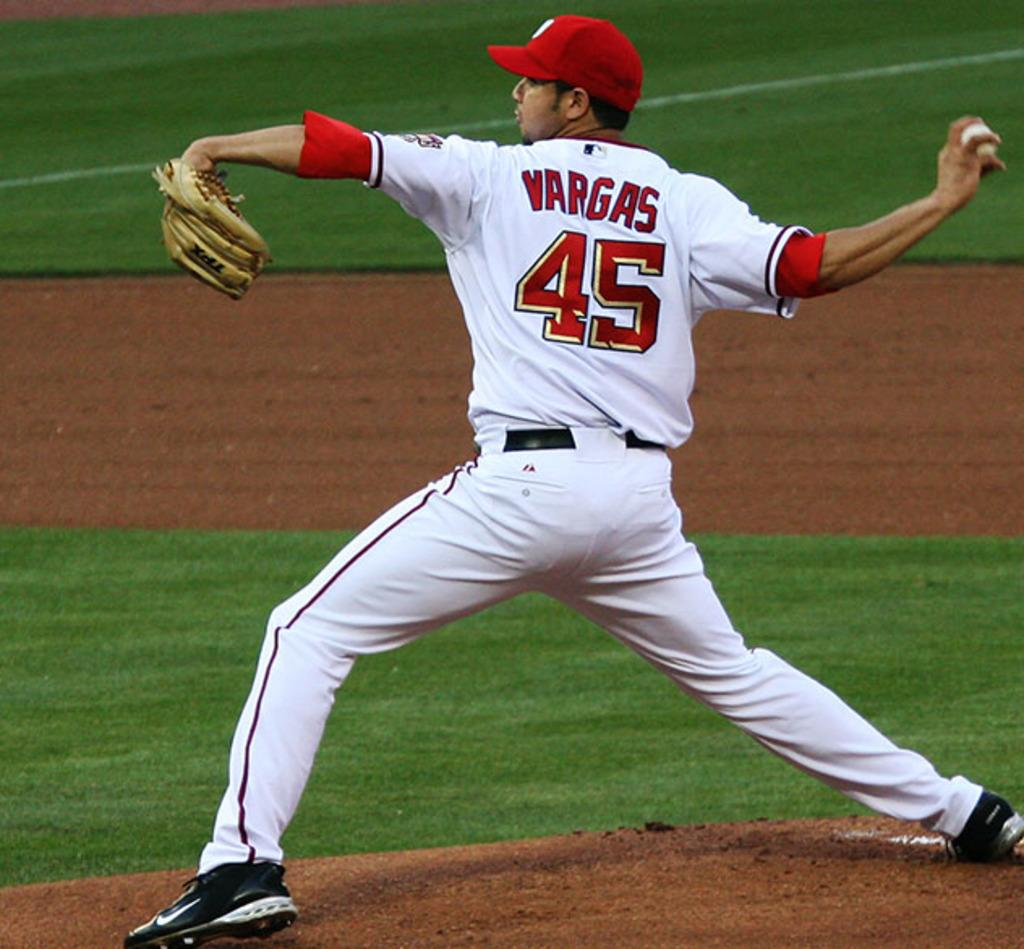Provide a one-sentence caption for the provided image. baseball pitcher with a circle englargment of a detail of grass. 